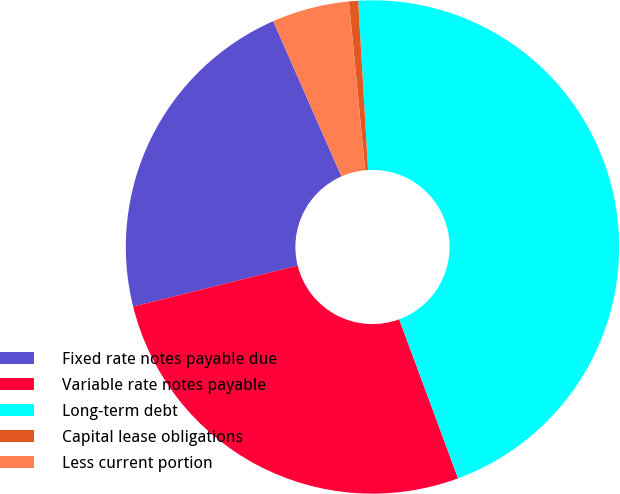Convert chart. <chart><loc_0><loc_0><loc_500><loc_500><pie_chart><fcel>Fixed rate notes payable due<fcel>Variable rate notes payable<fcel>Long-term debt<fcel>Capital lease obligations<fcel>Less current portion<nl><fcel>22.29%<fcel>26.76%<fcel>45.28%<fcel>0.6%<fcel>5.07%<nl></chart> 